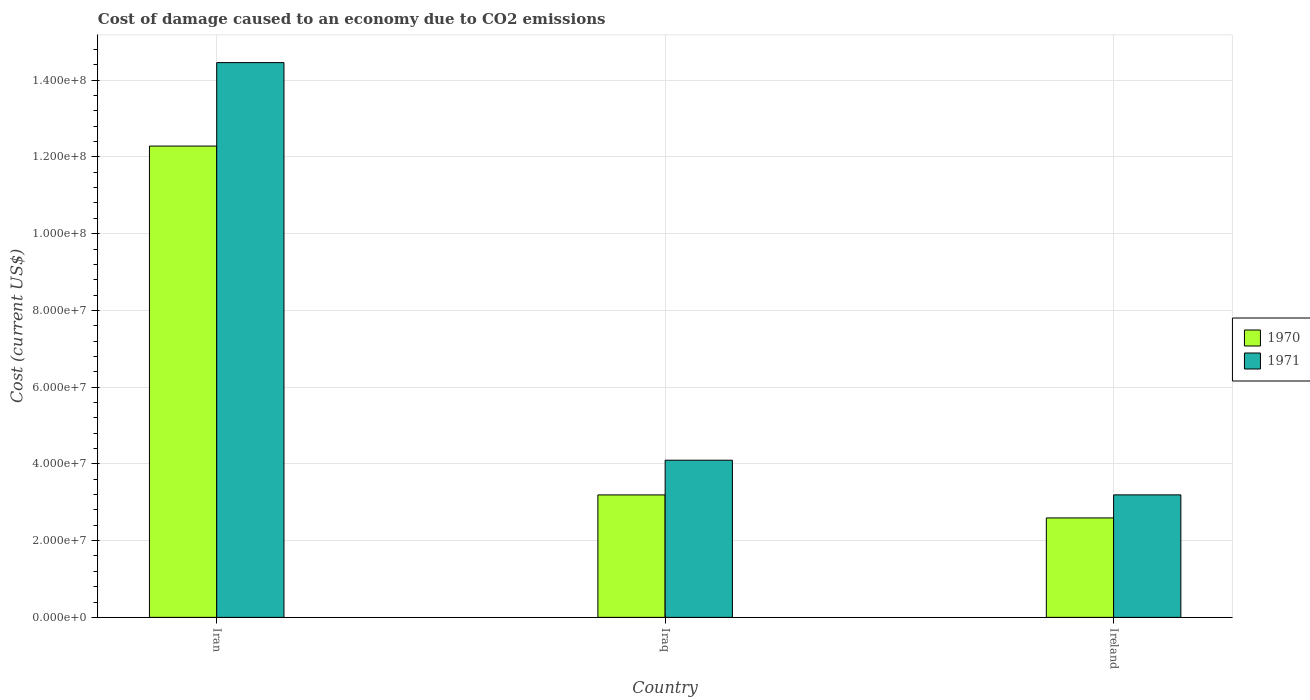Are the number of bars per tick equal to the number of legend labels?
Offer a very short reply. Yes. How many bars are there on the 2nd tick from the right?
Your response must be concise. 2. What is the label of the 3rd group of bars from the left?
Offer a very short reply. Ireland. What is the cost of damage caused due to CO2 emissisons in 1971 in Iraq?
Offer a terse response. 4.10e+07. Across all countries, what is the maximum cost of damage caused due to CO2 emissisons in 1970?
Your answer should be compact. 1.23e+08. Across all countries, what is the minimum cost of damage caused due to CO2 emissisons in 1971?
Ensure brevity in your answer.  3.19e+07. In which country was the cost of damage caused due to CO2 emissisons in 1971 maximum?
Keep it short and to the point. Iran. In which country was the cost of damage caused due to CO2 emissisons in 1971 minimum?
Your answer should be compact. Ireland. What is the total cost of damage caused due to CO2 emissisons in 1970 in the graph?
Provide a short and direct response. 1.81e+08. What is the difference between the cost of damage caused due to CO2 emissisons in 1970 in Iraq and that in Ireland?
Offer a very short reply. 6.00e+06. What is the difference between the cost of damage caused due to CO2 emissisons in 1970 in Iraq and the cost of damage caused due to CO2 emissisons in 1971 in Ireland?
Your answer should be compact. -1.12e+04. What is the average cost of damage caused due to CO2 emissisons in 1970 per country?
Provide a succinct answer. 6.02e+07. What is the difference between the cost of damage caused due to CO2 emissisons of/in 1971 and cost of damage caused due to CO2 emissisons of/in 1970 in Iran?
Offer a terse response. 2.18e+07. In how many countries, is the cost of damage caused due to CO2 emissisons in 1970 greater than 36000000 US$?
Provide a short and direct response. 1. What is the ratio of the cost of damage caused due to CO2 emissisons in 1970 in Iran to that in Iraq?
Offer a very short reply. 3.85. Is the cost of damage caused due to CO2 emissisons in 1970 in Iraq less than that in Ireland?
Offer a very short reply. No. Is the difference between the cost of damage caused due to CO2 emissisons in 1971 in Iran and Ireland greater than the difference between the cost of damage caused due to CO2 emissisons in 1970 in Iran and Ireland?
Keep it short and to the point. Yes. What is the difference between the highest and the second highest cost of damage caused due to CO2 emissisons in 1971?
Your answer should be compact. 9.03e+06. What is the difference between the highest and the lowest cost of damage caused due to CO2 emissisons in 1971?
Your answer should be very brief. 1.13e+08. In how many countries, is the cost of damage caused due to CO2 emissisons in 1970 greater than the average cost of damage caused due to CO2 emissisons in 1970 taken over all countries?
Keep it short and to the point. 1. Is the sum of the cost of damage caused due to CO2 emissisons in 1971 in Iraq and Ireland greater than the maximum cost of damage caused due to CO2 emissisons in 1970 across all countries?
Your answer should be compact. No. What does the 2nd bar from the right in Ireland represents?
Provide a succinct answer. 1970. Are all the bars in the graph horizontal?
Ensure brevity in your answer.  No. What is the difference between two consecutive major ticks on the Y-axis?
Provide a short and direct response. 2.00e+07. Does the graph contain any zero values?
Your response must be concise. No. Does the graph contain grids?
Offer a terse response. Yes. Where does the legend appear in the graph?
Provide a short and direct response. Center right. What is the title of the graph?
Provide a short and direct response. Cost of damage caused to an economy due to CO2 emissions. Does "1975" appear as one of the legend labels in the graph?
Offer a very short reply. No. What is the label or title of the Y-axis?
Offer a very short reply. Cost (current US$). What is the Cost (current US$) in 1970 in Iran?
Keep it short and to the point. 1.23e+08. What is the Cost (current US$) of 1971 in Iran?
Your answer should be compact. 1.45e+08. What is the Cost (current US$) in 1970 in Iraq?
Make the answer very short. 3.19e+07. What is the Cost (current US$) in 1971 in Iraq?
Make the answer very short. 4.10e+07. What is the Cost (current US$) in 1970 in Ireland?
Provide a short and direct response. 2.59e+07. What is the Cost (current US$) in 1971 in Ireland?
Provide a succinct answer. 3.19e+07. Across all countries, what is the maximum Cost (current US$) of 1970?
Provide a succinct answer. 1.23e+08. Across all countries, what is the maximum Cost (current US$) of 1971?
Offer a very short reply. 1.45e+08. Across all countries, what is the minimum Cost (current US$) of 1970?
Offer a very short reply. 2.59e+07. Across all countries, what is the minimum Cost (current US$) in 1971?
Your answer should be compact. 3.19e+07. What is the total Cost (current US$) of 1970 in the graph?
Offer a very short reply. 1.81e+08. What is the total Cost (current US$) in 1971 in the graph?
Your response must be concise. 2.17e+08. What is the difference between the Cost (current US$) in 1970 in Iran and that in Iraq?
Offer a very short reply. 9.09e+07. What is the difference between the Cost (current US$) of 1971 in Iran and that in Iraq?
Ensure brevity in your answer.  1.04e+08. What is the difference between the Cost (current US$) in 1970 in Iran and that in Ireland?
Offer a terse response. 9.69e+07. What is the difference between the Cost (current US$) in 1971 in Iran and that in Ireland?
Keep it short and to the point. 1.13e+08. What is the difference between the Cost (current US$) in 1970 in Iraq and that in Ireland?
Your response must be concise. 6.00e+06. What is the difference between the Cost (current US$) of 1971 in Iraq and that in Ireland?
Give a very brief answer. 9.03e+06. What is the difference between the Cost (current US$) of 1970 in Iran and the Cost (current US$) of 1971 in Iraq?
Ensure brevity in your answer.  8.19e+07. What is the difference between the Cost (current US$) in 1970 in Iran and the Cost (current US$) in 1971 in Ireland?
Provide a short and direct response. 9.09e+07. What is the difference between the Cost (current US$) in 1970 in Iraq and the Cost (current US$) in 1971 in Ireland?
Keep it short and to the point. -1.12e+04. What is the average Cost (current US$) in 1970 per country?
Provide a succinct answer. 6.02e+07. What is the average Cost (current US$) in 1971 per country?
Offer a terse response. 7.25e+07. What is the difference between the Cost (current US$) of 1970 and Cost (current US$) of 1971 in Iran?
Give a very brief answer. -2.18e+07. What is the difference between the Cost (current US$) of 1970 and Cost (current US$) of 1971 in Iraq?
Provide a succinct answer. -9.04e+06. What is the difference between the Cost (current US$) in 1970 and Cost (current US$) in 1971 in Ireland?
Your answer should be very brief. -6.01e+06. What is the ratio of the Cost (current US$) in 1970 in Iran to that in Iraq?
Give a very brief answer. 3.85. What is the ratio of the Cost (current US$) of 1971 in Iran to that in Iraq?
Your answer should be very brief. 3.53. What is the ratio of the Cost (current US$) of 1970 in Iran to that in Ireland?
Offer a terse response. 4.74. What is the ratio of the Cost (current US$) in 1971 in Iran to that in Ireland?
Offer a very short reply. 4.53. What is the ratio of the Cost (current US$) in 1970 in Iraq to that in Ireland?
Your response must be concise. 1.23. What is the ratio of the Cost (current US$) in 1971 in Iraq to that in Ireland?
Your answer should be very brief. 1.28. What is the difference between the highest and the second highest Cost (current US$) of 1970?
Provide a succinct answer. 9.09e+07. What is the difference between the highest and the second highest Cost (current US$) in 1971?
Offer a very short reply. 1.04e+08. What is the difference between the highest and the lowest Cost (current US$) in 1970?
Offer a very short reply. 9.69e+07. What is the difference between the highest and the lowest Cost (current US$) in 1971?
Provide a short and direct response. 1.13e+08. 